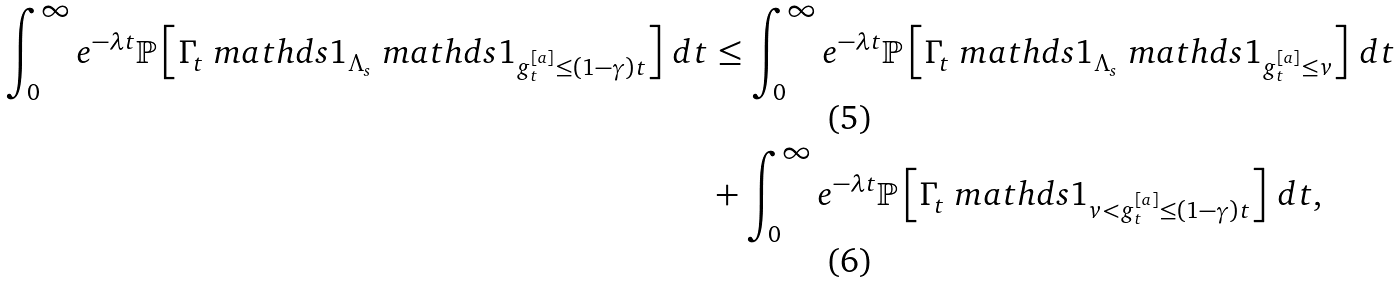<formula> <loc_0><loc_0><loc_500><loc_500>\int _ { 0 } ^ { \infty } e ^ { - \lambda t } \mathbb { P } \left [ \Gamma _ { t } \ m a t h d s { 1 } _ { \Lambda _ { s } } \ m a t h d s { 1 } _ { g _ { t } ^ { [ a ] } \leq ( 1 - \gamma ) t } \right ] \, d t & \leq \int _ { 0 } ^ { \infty } e ^ { - \lambda t } \mathbb { P } \left [ \Gamma _ { t } \ m a t h d s { 1 } _ { \Lambda _ { s } } \ m a t h d s { 1 } _ { g _ { t } ^ { [ a ] } \leq v } \right ] \, d t \\ & + \int _ { 0 } ^ { \infty } e ^ { - \lambda t } \mathbb { P } \left [ \Gamma _ { t } \ m a t h d s { 1 } _ { v < g _ { t } ^ { [ a ] } \leq ( 1 - \gamma ) t } \right ] \, d t ,</formula> 